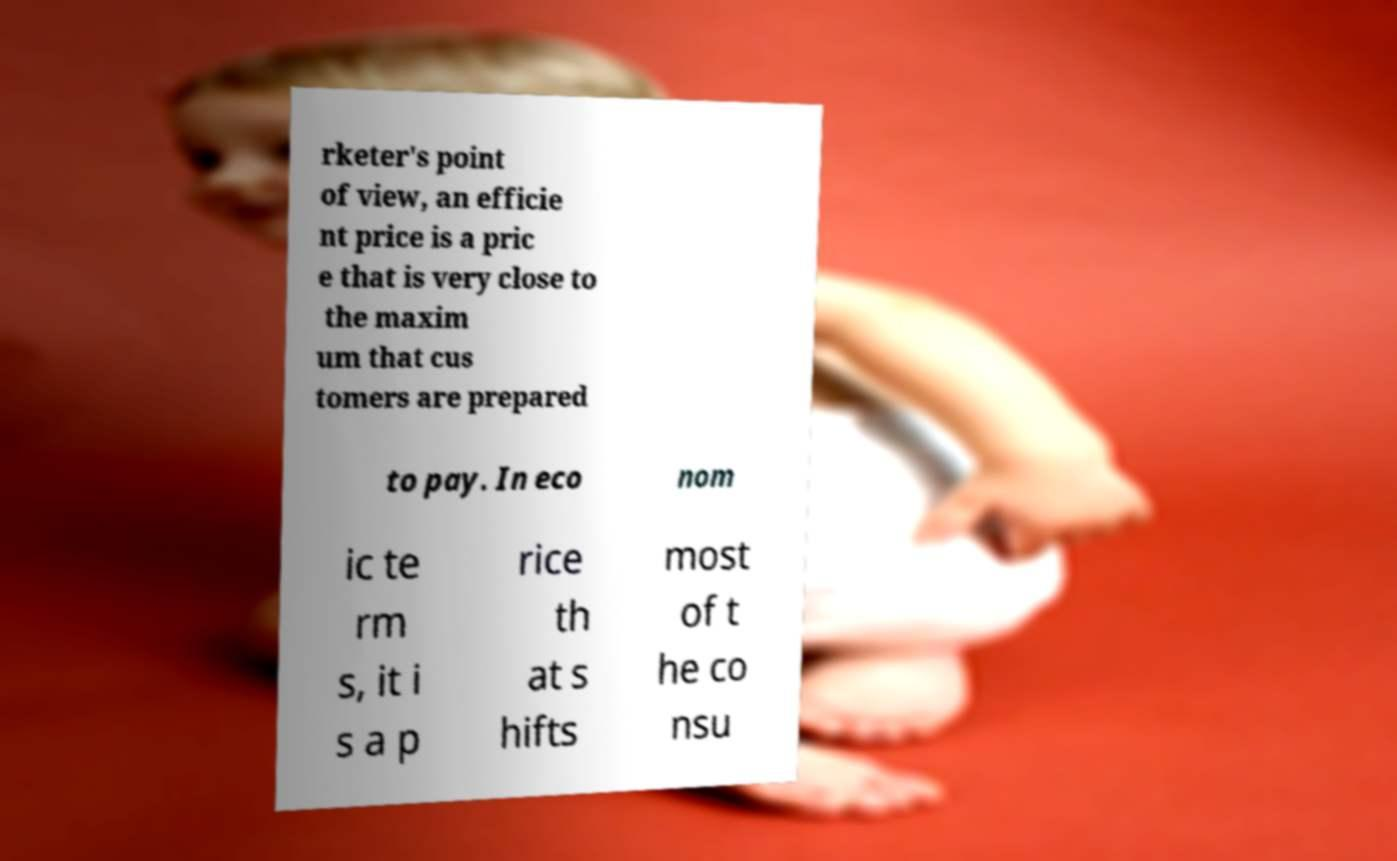Please read and relay the text visible in this image. What does it say? rketer's point of view, an efficie nt price is a pric e that is very close to the maxim um that cus tomers are prepared to pay. In eco nom ic te rm s, it i s a p rice th at s hifts most of t he co nsu 